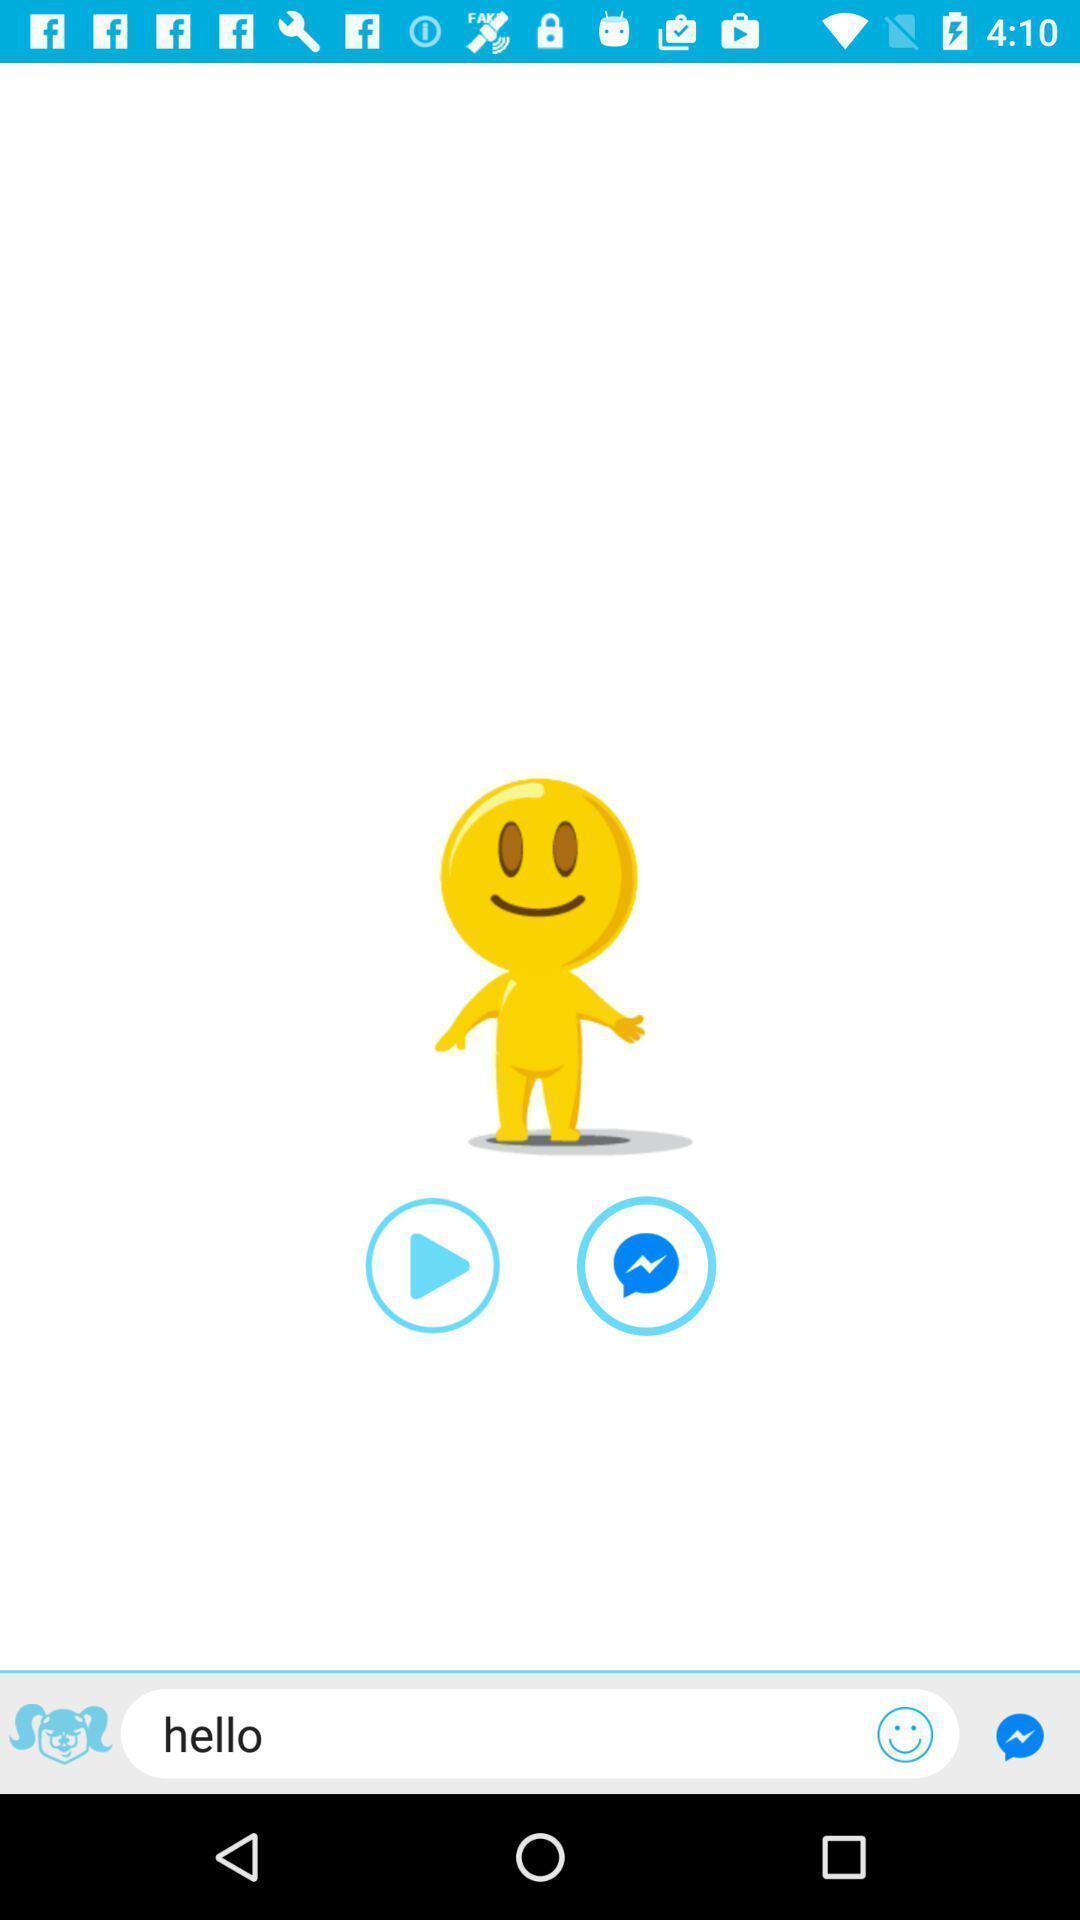Explain the elements present in this screenshot. Page displays a cartoon image. 